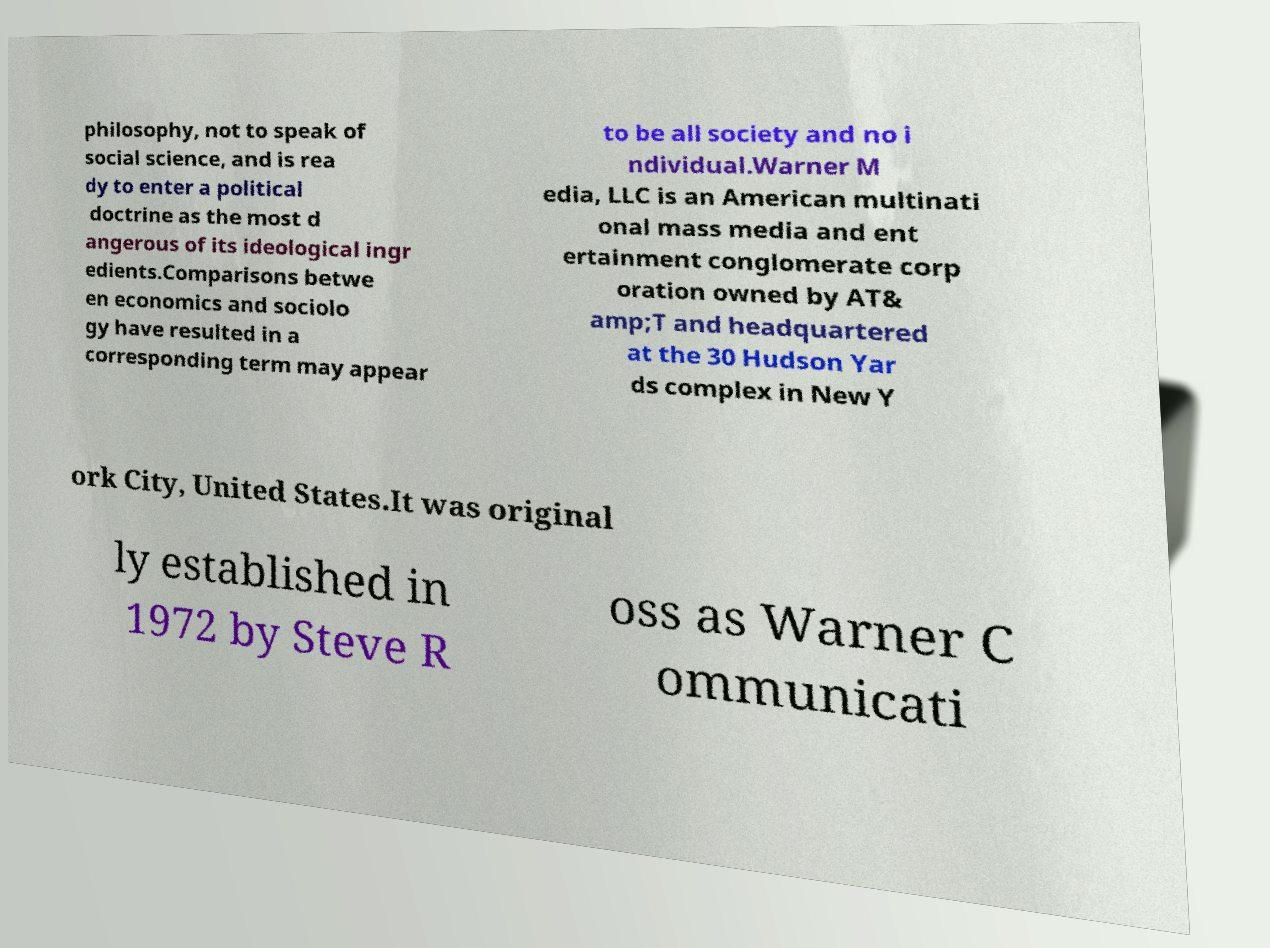Could you assist in decoding the text presented in this image and type it out clearly? philosophy, not to speak of social science, and is rea dy to enter a political doctrine as the most d angerous of its ideological ingr edients.Comparisons betwe en economics and sociolo gy have resulted in a corresponding term may appear to be all society and no i ndividual.Warner M edia, LLC is an American multinati onal mass media and ent ertainment conglomerate corp oration owned by AT& amp;T and headquartered at the 30 Hudson Yar ds complex in New Y ork City, United States.It was original ly established in 1972 by Steve R oss as Warner C ommunicati 